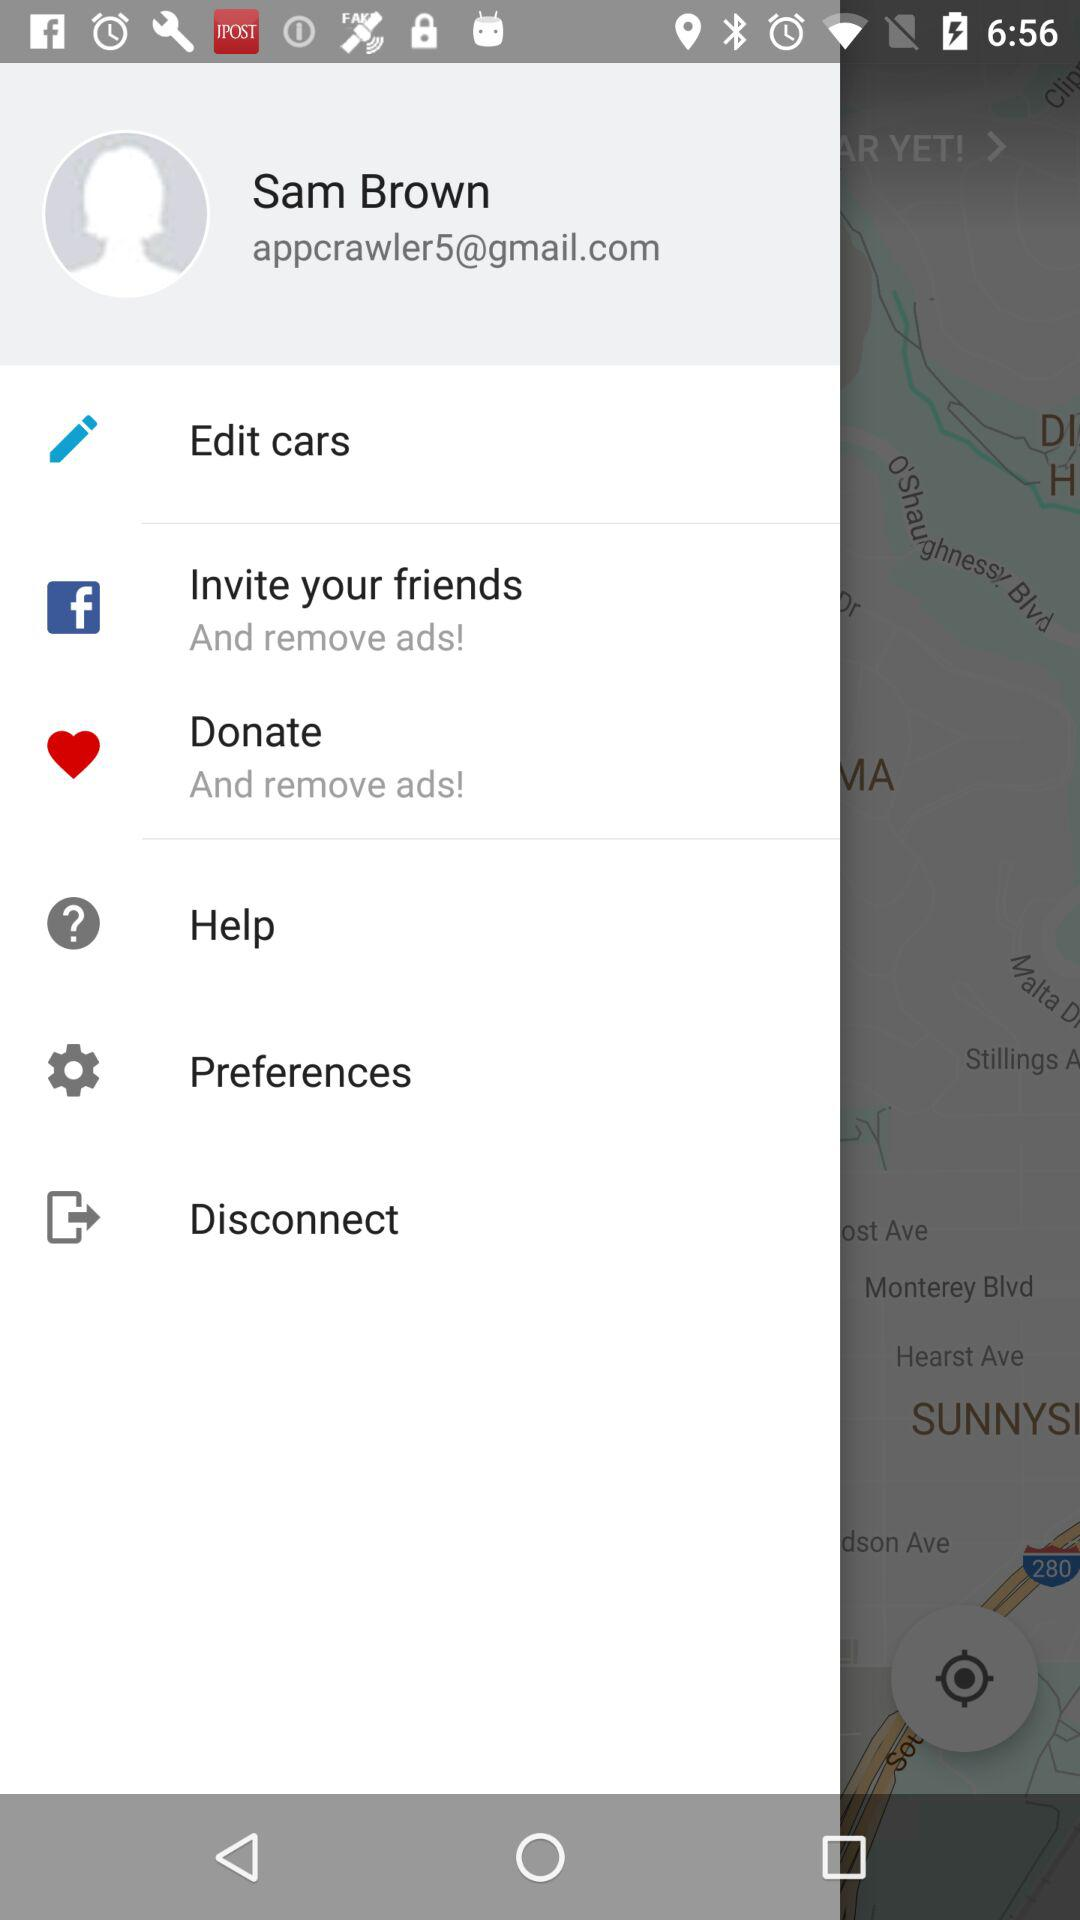What is the user name? The user name is Sam Brown. 